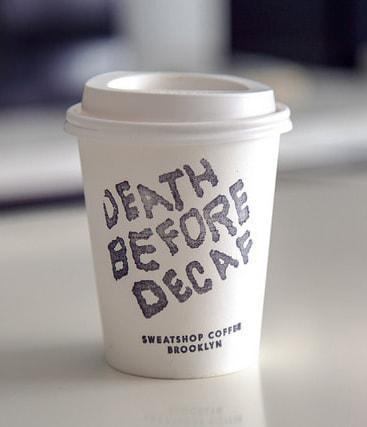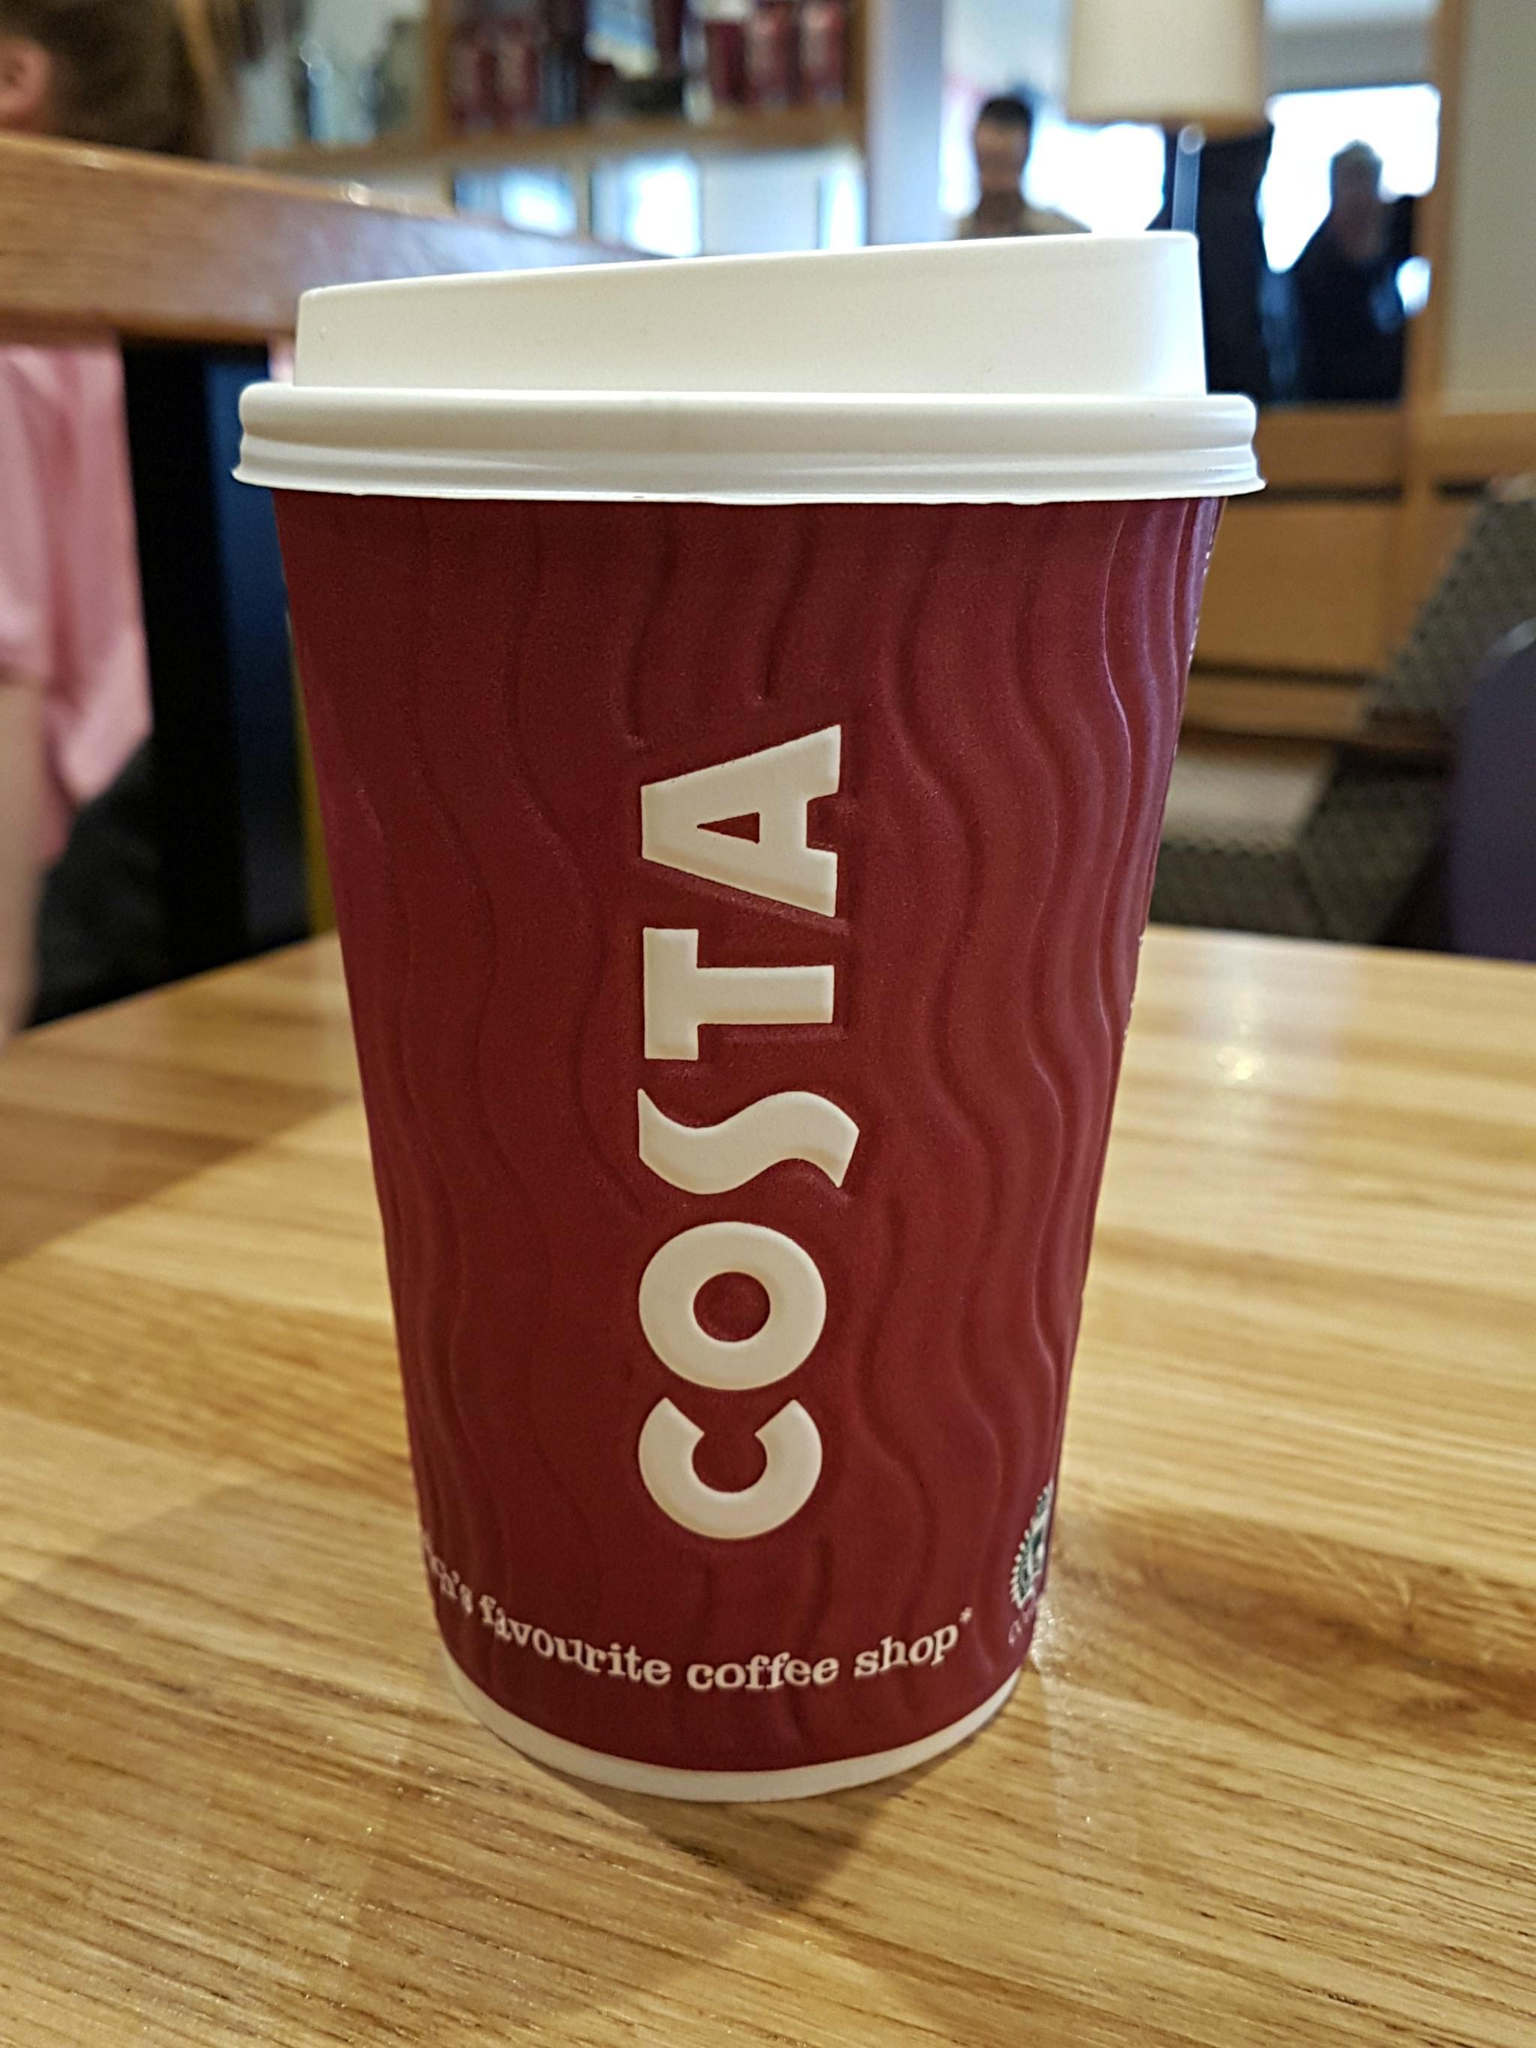The first image is the image on the left, the second image is the image on the right. Assess this claim about the two images: "There are exactly two cups.". Correct or not? Answer yes or no. Yes. The first image is the image on the left, the second image is the image on the right. For the images displayed, is the sentence "There are only two disposable coffee cups." factually correct? Answer yes or no. Yes. 